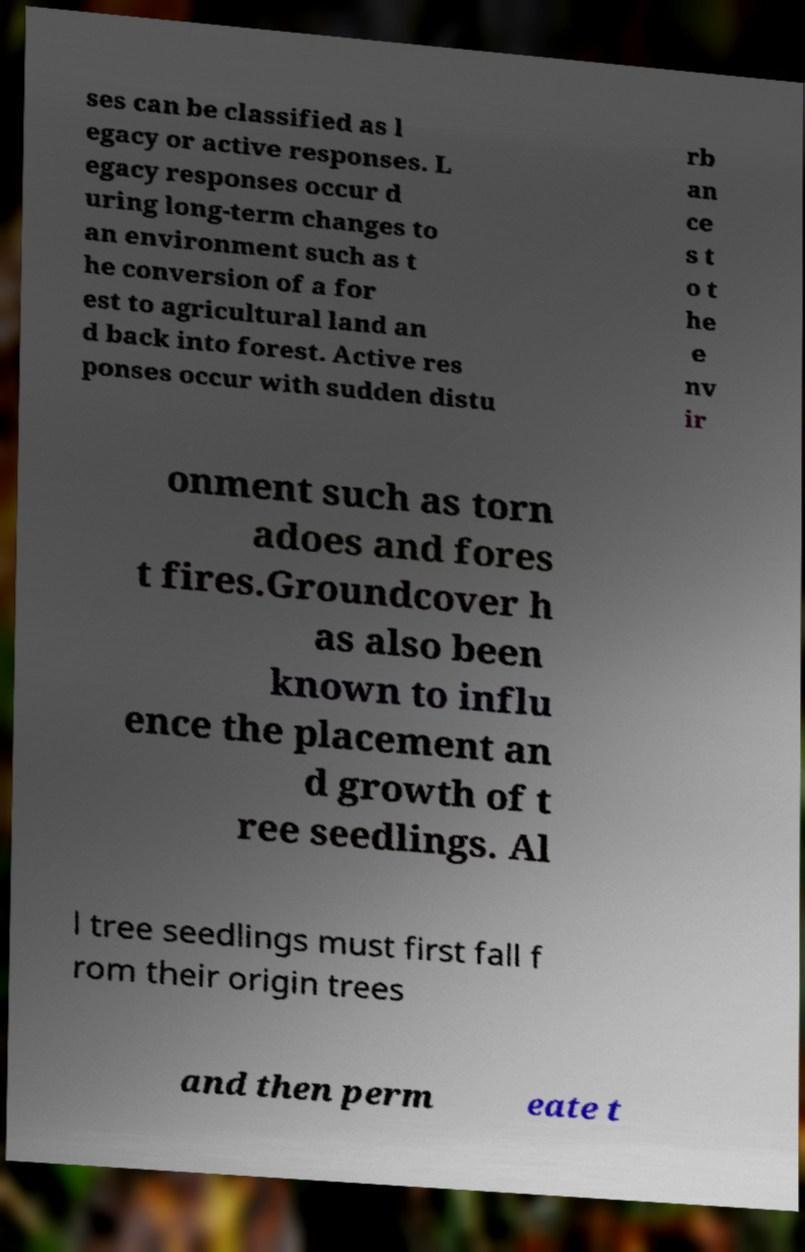There's text embedded in this image that I need extracted. Can you transcribe it verbatim? ses can be classified as l egacy or active responses. L egacy responses occur d uring long-term changes to an environment such as t he conversion of a for est to agricultural land an d back into forest. Active res ponses occur with sudden distu rb an ce s t o t he e nv ir onment such as torn adoes and fores t fires.Groundcover h as also been known to influ ence the placement an d growth of t ree seedlings. Al l tree seedlings must first fall f rom their origin trees and then perm eate t 